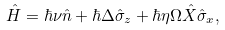Convert formula to latex. <formula><loc_0><loc_0><loc_500><loc_500>\hat { H } = \hbar { \nu } \hat { n } + \hbar { \Delta } \hat { \sigma } _ { z } + \hbar { \eta } \Omega \hat { X } \hat { \sigma } _ { x } ,</formula> 